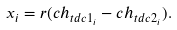Convert formula to latex. <formula><loc_0><loc_0><loc_500><loc_500>x _ { i } = r ( c h _ { t d c 1 _ { i } } - c h _ { t d c 2 _ { i } } ) .</formula> 